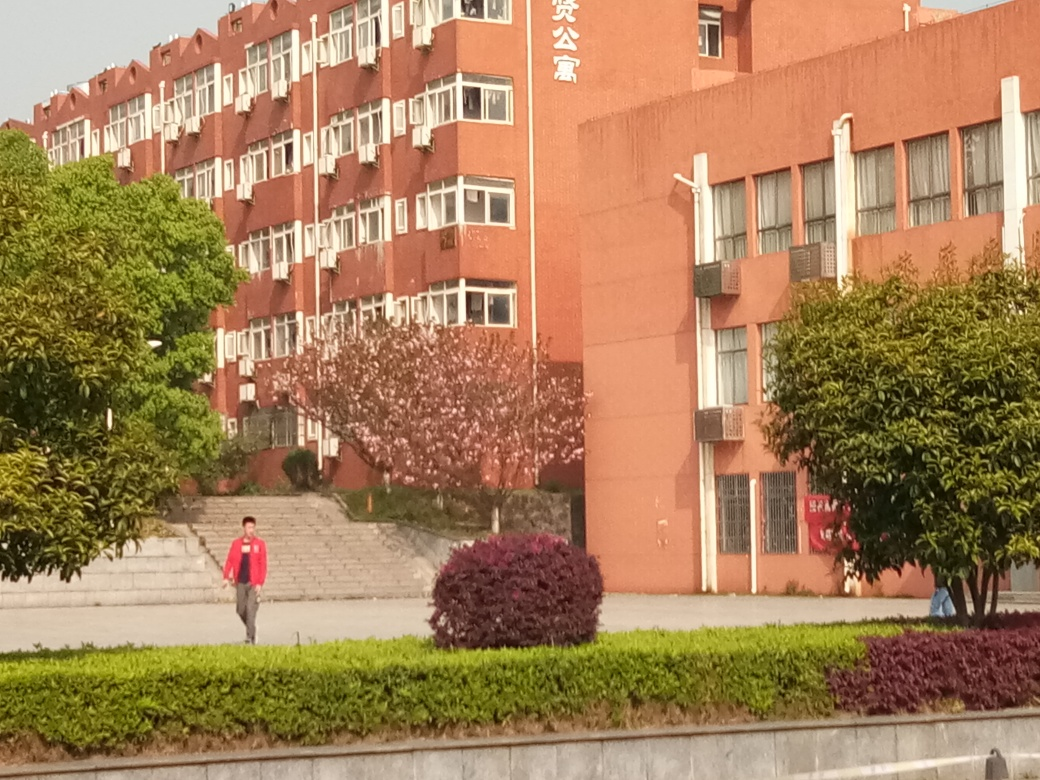Are the colors rich? The image indeed displays a rich color palette, with the vibrant reds of the building's facade contrasting beautifully with the varied greens of the foliage and the subtle pink hues of the blossoming tree. The composition of these colors provides a vivacious and dynamic visual experience. 